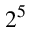Convert formula to latex. <formula><loc_0><loc_0><loc_500><loc_500>2 ^ { 5 }</formula> 